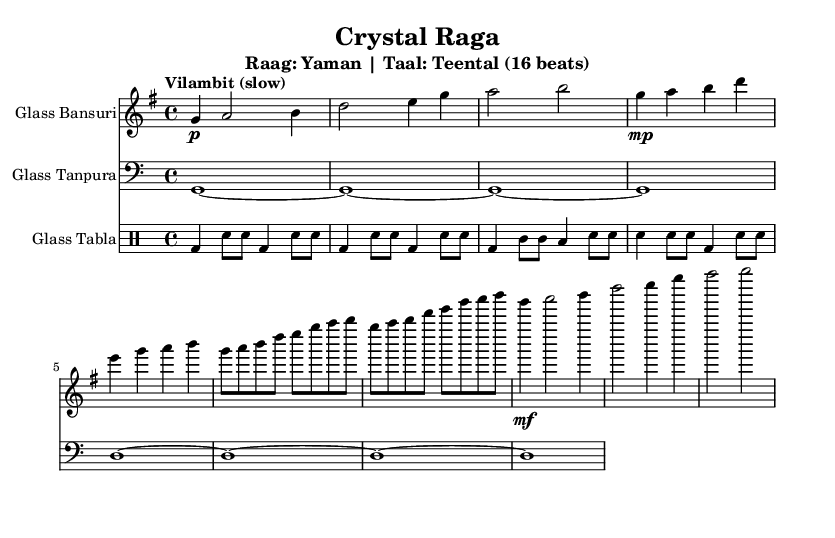What is the time signature of this music? The time signature is shown at the beginning of the piece and indicates it is in 4/4 time, which means there are four beats per measure.
Answer: 4/4 What is the key signature of this music? The key signature is indicated at the beginning and features one sharp, which corresponds to G major.
Answer: G major What is the tempo marking of the piece? The tempo marking is included in the music and states "Vilambit (slow)," indicating a slow tempo for the performance.
Answer: Vilambit (slow) What is the first instrument in the score? The first staff shows "Glass Bansuri," indicating that this is the first instrument notated in the score.
Answer: Glass Bansuri How many beats are in a measure based on the time signature? The time signature is 4/4, which means there are four beats in each measure of the music.
Answer: Four What type of rhythm does the tabla part start with? The tabla part begins with a pattern featuring bass drum hits followed by snare hits, which creates a characteristic rhythmic feel for this genre.
Answer: Bass and snare What is the structure of the initial section of the piece? The music starts with an Alap section followed by a Jor and then a Jhala before moving to the Gat, showcasing a common structure in Indian classical music.
Answer: Alap, Jor, Jhala, Gat 